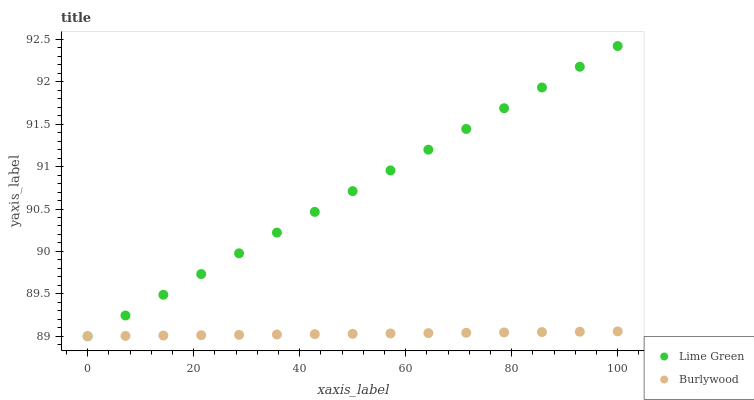Does Burlywood have the minimum area under the curve?
Answer yes or no. Yes. Does Lime Green have the maximum area under the curve?
Answer yes or no. Yes. Does Lime Green have the minimum area under the curve?
Answer yes or no. No. Is Burlywood the smoothest?
Answer yes or no. Yes. Is Lime Green the roughest?
Answer yes or no. Yes. Is Lime Green the smoothest?
Answer yes or no. No. Does Burlywood have the lowest value?
Answer yes or no. Yes. Does Lime Green have the highest value?
Answer yes or no. Yes. Does Lime Green intersect Burlywood?
Answer yes or no. Yes. Is Lime Green less than Burlywood?
Answer yes or no. No. Is Lime Green greater than Burlywood?
Answer yes or no. No. 